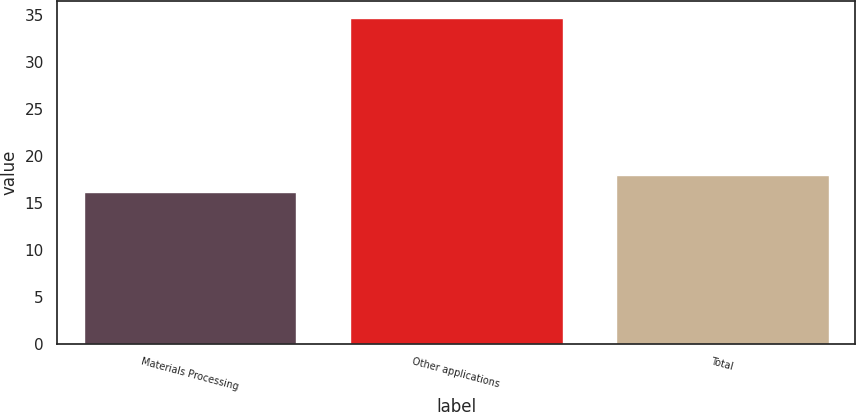Convert chart to OTSL. <chart><loc_0><loc_0><loc_500><loc_500><bar_chart><fcel>Materials Processing<fcel>Other applications<fcel>Total<nl><fcel>16.1<fcel>34.7<fcel>17.96<nl></chart> 